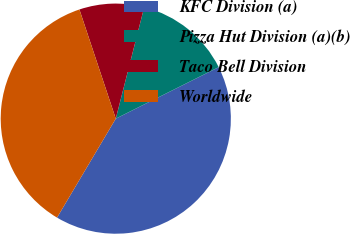<chart> <loc_0><loc_0><loc_500><loc_500><pie_chart><fcel>KFC Division (a)<fcel>Pizza Hut Division (a)(b)<fcel>Taco Bell Division<fcel>Worldwide<nl><fcel>40.91%<fcel>13.64%<fcel>9.09%<fcel>36.36%<nl></chart> 